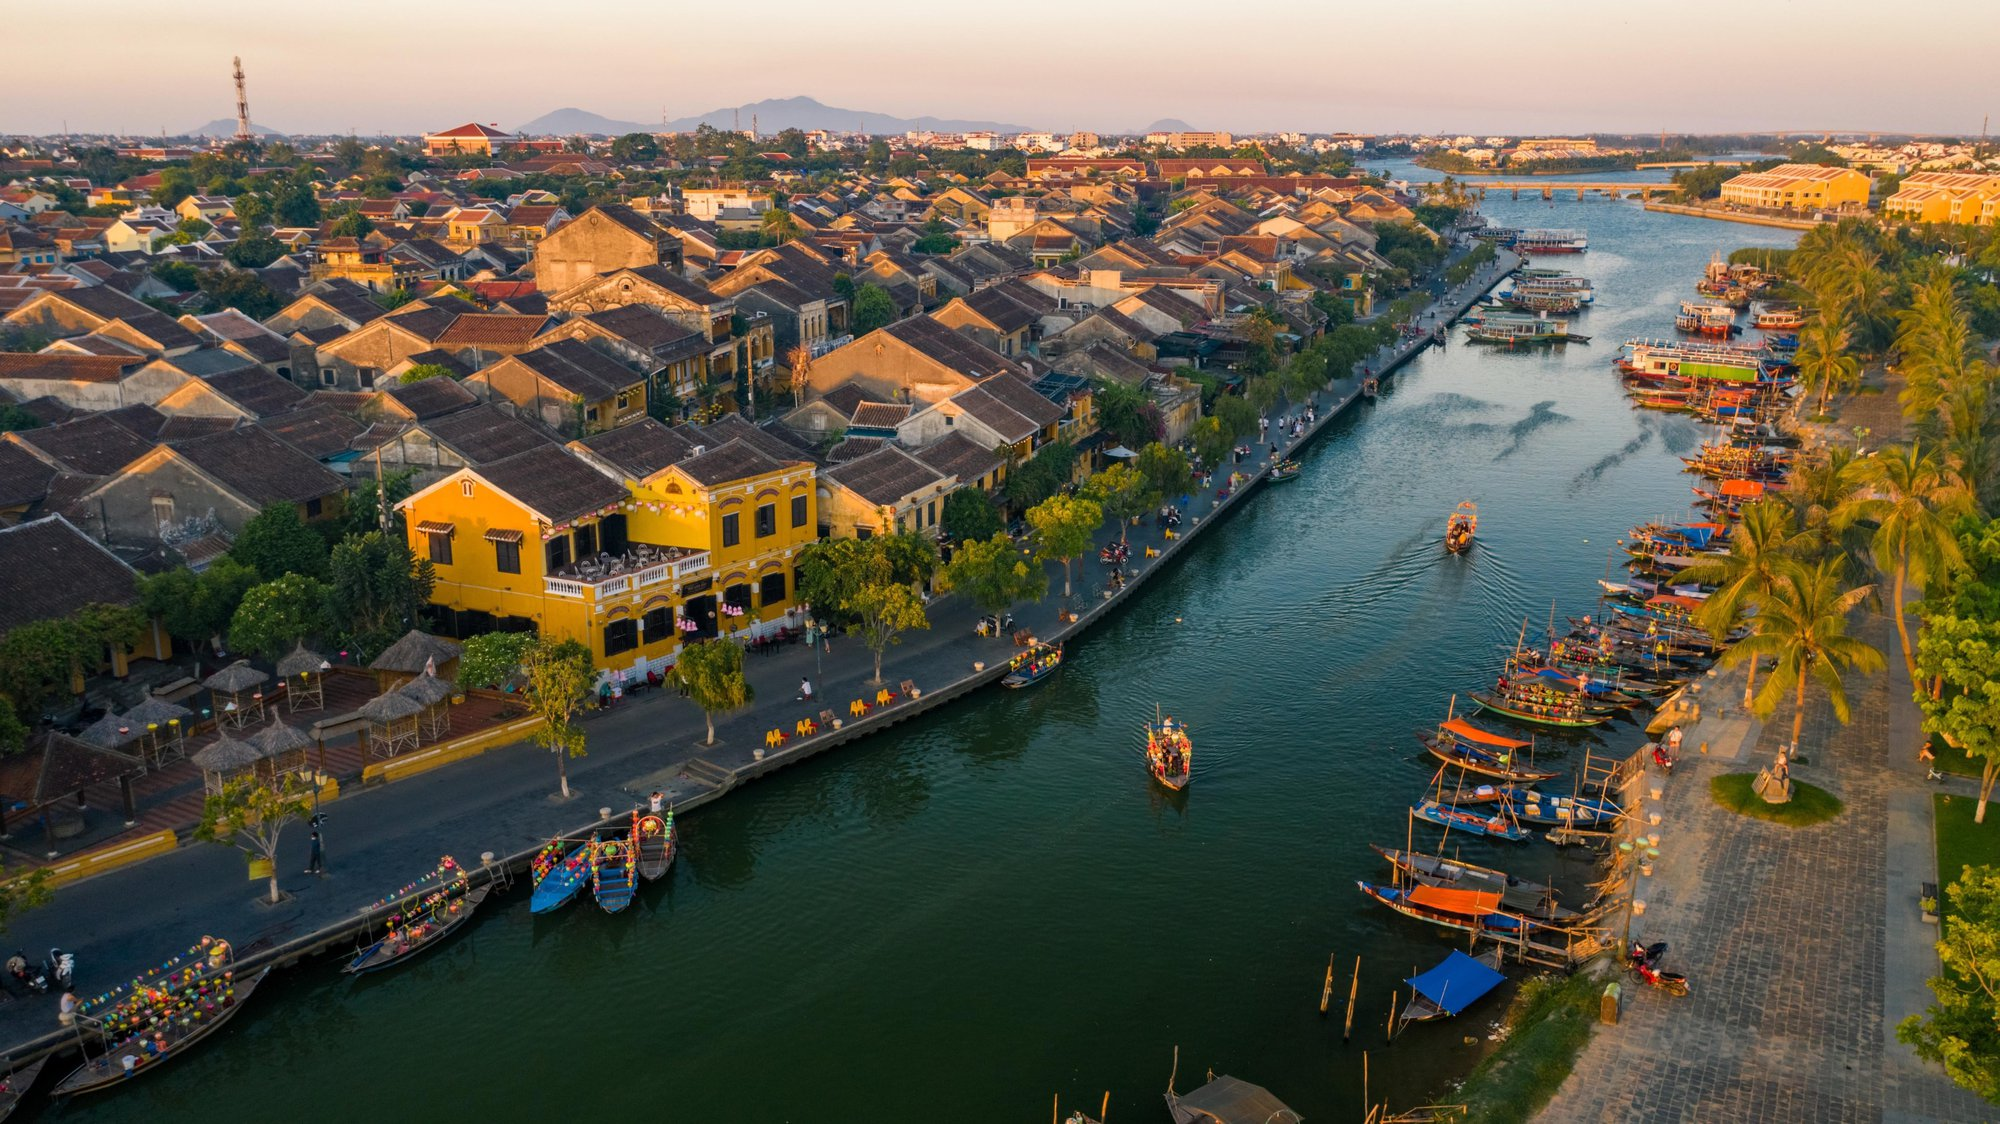What might be the impact of heavy rain on this riverside community? Heavy rain could potentially have significant impacts on this riverside community. The elevated water levels might pose a threat of flooding to the buildings and streets closest to the river. The traditional wooden boats, which are so integral to daily life and tourism, could be damaged or become difficult to navigate in strong currents and high waters. Commerce and daily activities might be disrupted, and there could be economic consequences, especially if tourism is affected. Additionally, if the rainfall is prolonged, it might also compromise the structural integrity of the buildings, many of which appear to be historical. On the flip side, the community likely has systems and traditions in place to cope with such natural occurrences, given their close relationship with the river. 